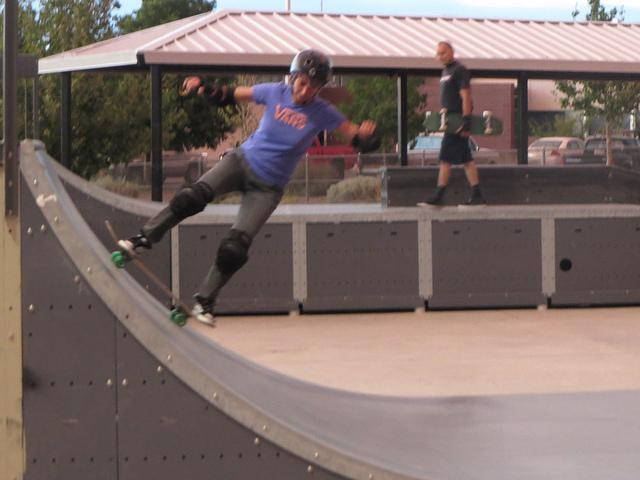On the front man what is most protected? knees 